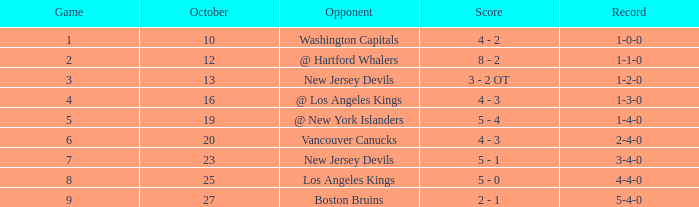What was the average game with a record of 4-4-0? 8.0. 